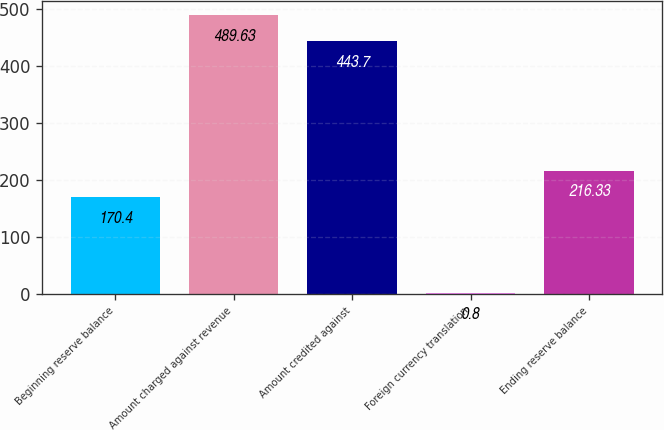Convert chart to OTSL. <chart><loc_0><loc_0><loc_500><loc_500><bar_chart><fcel>Beginning reserve balance<fcel>Amount charged against revenue<fcel>Amount credited against<fcel>Foreign currency translation<fcel>Ending reserve balance<nl><fcel>170.4<fcel>489.63<fcel>443.7<fcel>0.8<fcel>216.33<nl></chart> 